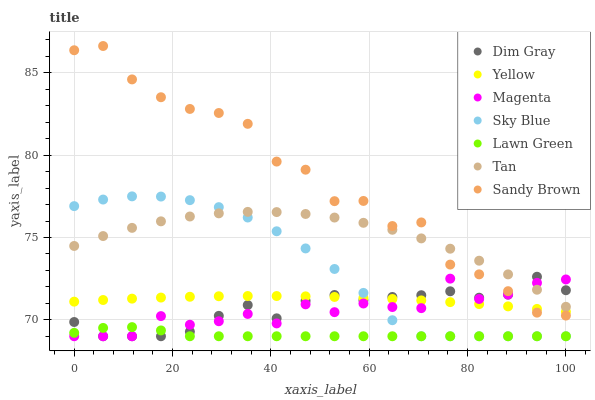Does Lawn Green have the minimum area under the curve?
Answer yes or no. Yes. Does Sandy Brown have the maximum area under the curve?
Answer yes or no. Yes. Does Dim Gray have the minimum area under the curve?
Answer yes or no. No. Does Dim Gray have the maximum area under the curve?
Answer yes or no. No. Is Yellow the smoothest?
Answer yes or no. Yes. Is Sandy Brown the roughest?
Answer yes or no. Yes. Is Dim Gray the smoothest?
Answer yes or no. No. Is Dim Gray the roughest?
Answer yes or no. No. Does Lawn Green have the lowest value?
Answer yes or no. Yes. Does Yellow have the lowest value?
Answer yes or no. No. Does Sandy Brown have the highest value?
Answer yes or no. Yes. Does Dim Gray have the highest value?
Answer yes or no. No. Is Lawn Green less than Yellow?
Answer yes or no. Yes. Is Tan greater than Yellow?
Answer yes or no. Yes. Does Yellow intersect Magenta?
Answer yes or no. Yes. Is Yellow less than Magenta?
Answer yes or no. No. Is Yellow greater than Magenta?
Answer yes or no. No. Does Lawn Green intersect Yellow?
Answer yes or no. No. 